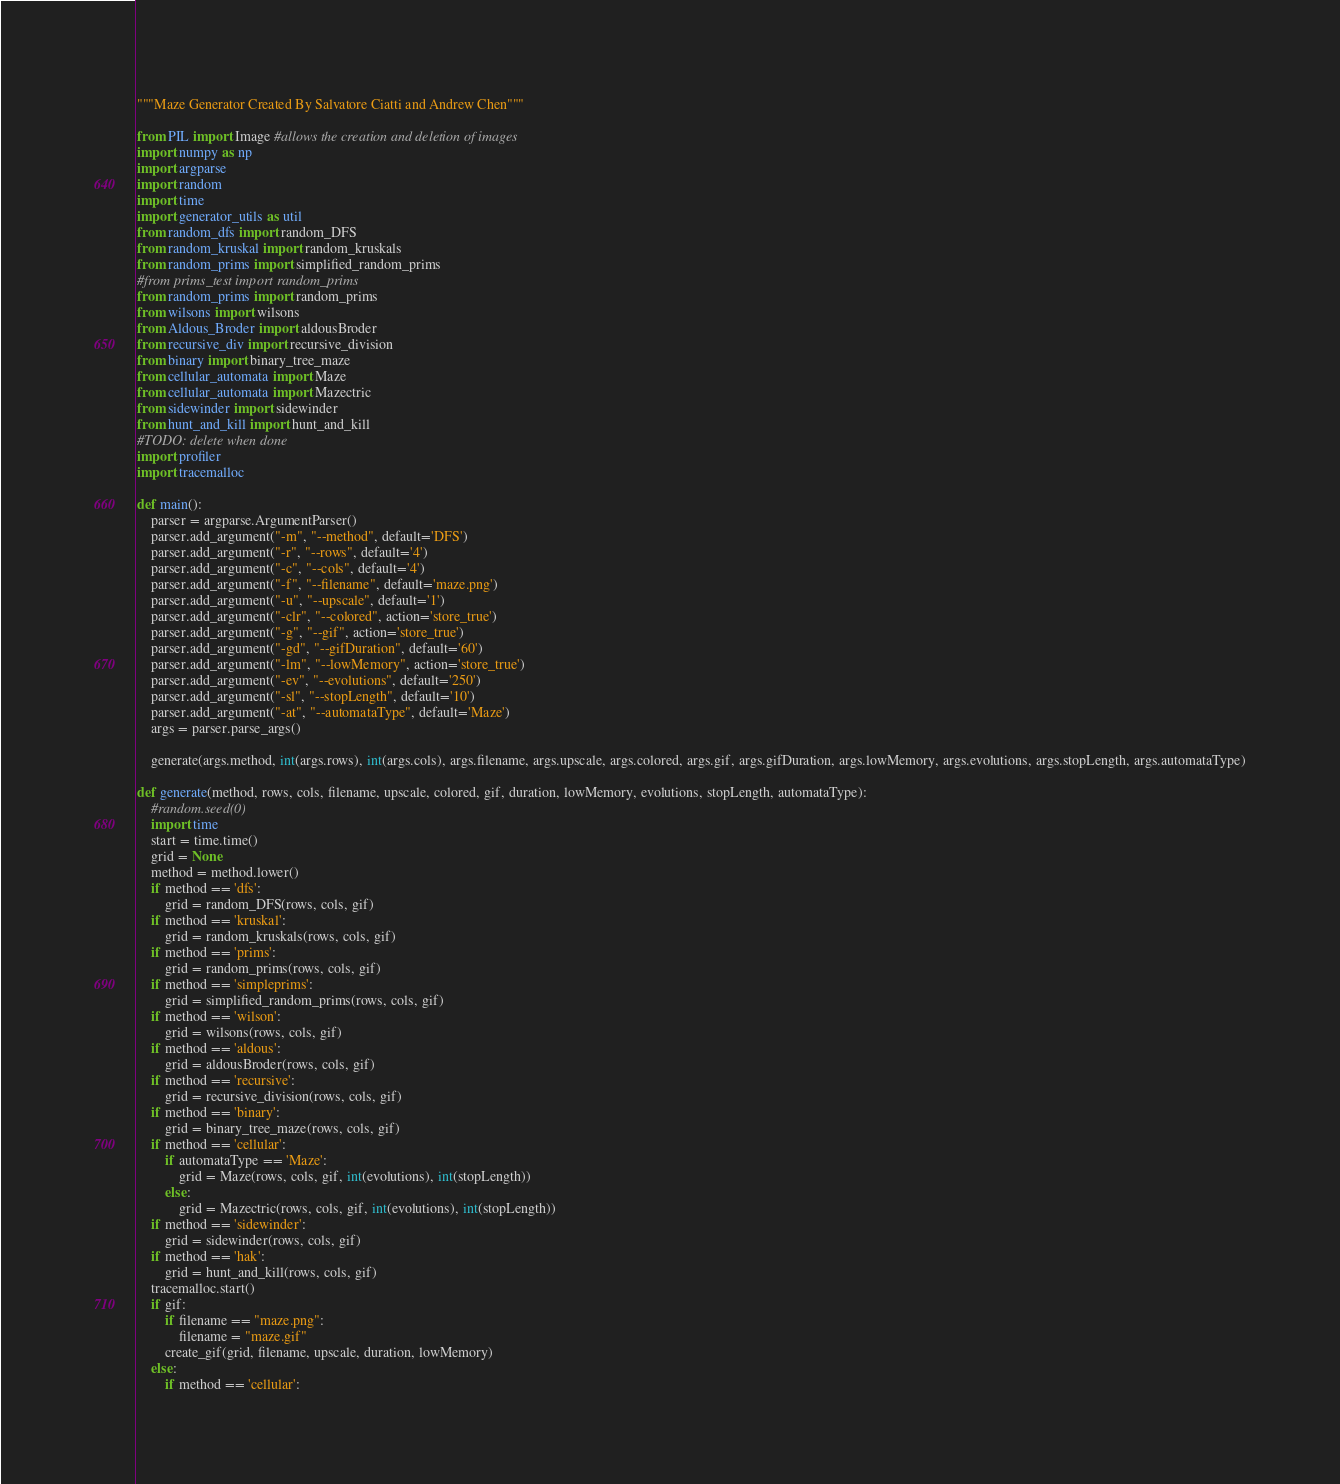Convert code to text. <code><loc_0><loc_0><loc_500><loc_500><_Python_>"""Maze Generator Created By Salvatore Ciatti and Andrew Chen"""

from PIL import Image #allows the creation and deletion of images
import numpy as np
import argparse
import random
import time
import generator_utils as util
from random_dfs import random_DFS
from random_kruskal import random_kruskals
from random_prims import simplified_random_prims
#from prims_test import random_prims
from random_prims import random_prims
from wilsons import wilsons
from Aldous_Broder import aldousBroder
from recursive_div import recursive_division
from binary import binary_tree_maze
from cellular_automata import Maze
from cellular_automata import Mazectric
from sidewinder import sidewinder
from hunt_and_kill import hunt_and_kill
#TODO: delete when done
import profiler
import tracemalloc

def main():
    parser = argparse.ArgumentParser()
    parser.add_argument("-m", "--method", default='DFS')
    parser.add_argument("-r", "--rows", default='4')
    parser.add_argument("-c", "--cols", default='4')
    parser.add_argument("-f", "--filename", default='maze.png')
    parser.add_argument("-u", "--upscale", default='1')
    parser.add_argument("-clr", "--colored", action='store_true')
    parser.add_argument("-g", "--gif", action='store_true')
    parser.add_argument("-gd", "--gifDuration", default='60')
    parser.add_argument("-lm", "--lowMemory", action='store_true')
    parser.add_argument("-ev", "--evolutions", default='250')
    parser.add_argument("-sl", "--stopLength", default='10')
    parser.add_argument("-at", "--automataType", default='Maze')
    args = parser.parse_args()

    generate(args.method, int(args.rows), int(args.cols), args.filename, args.upscale, args.colored, args.gif, args.gifDuration, args.lowMemory, args.evolutions, args.stopLength, args.automataType)

def generate(method, rows, cols, filename, upscale, colored, gif, duration, lowMemory, evolutions, stopLength, automataType):
    #random.seed(0)
    import time
    start = time.time()
    grid = None
    method = method.lower()
    if method == 'dfs':
        grid = random_DFS(rows, cols, gif)
    if method == 'kruskal':
        grid = random_kruskals(rows, cols, gif)
    if method == 'prims':
        grid = random_prims(rows, cols, gif)
    if method == 'simpleprims':
        grid = simplified_random_prims(rows, cols, gif)
    if method == 'wilson':
        grid = wilsons(rows, cols, gif)
    if method == 'aldous':
        grid = aldousBroder(rows, cols, gif)
    if method == 'recursive':
        grid = recursive_division(rows, cols, gif)
    if method == 'binary':
        grid = binary_tree_maze(rows, cols, gif)
    if method == 'cellular':
        if automataType == 'Maze':
            grid = Maze(rows, cols, gif, int(evolutions), int(stopLength))
        else:
            grid = Mazectric(rows, cols, gif, int(evolutions), int(stopLength))
    if method == 'sidewinder':
        grid = sidewinder(rows, cols, gif)
    if method == 'hak':
        grid = hunt_and_kill(rows, cols, gif)
    tracemalloc.start()    
    if gif:
        if filename == "maze.png":
            filename = "maze.gif"
        create_gif(grid, filename, upscale, duration, lowMemory)
    else:
        if method == 'cellular':</code> 